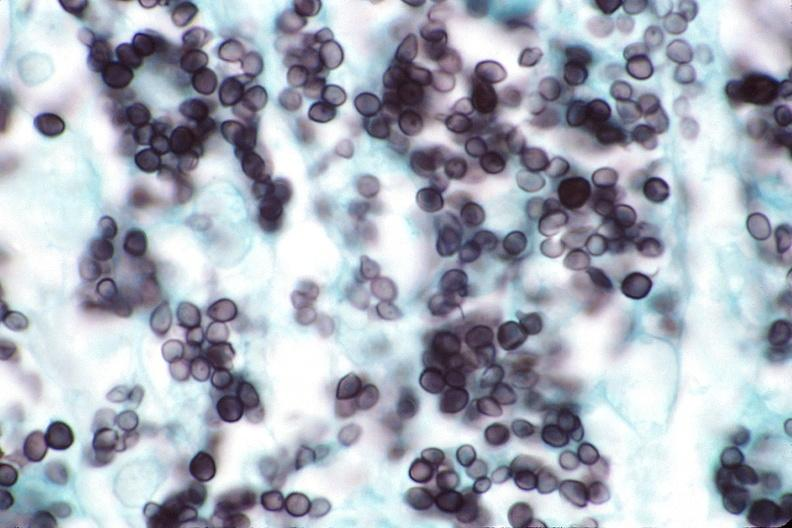where is this?
Answer the question using a single word or phrase. Lung 